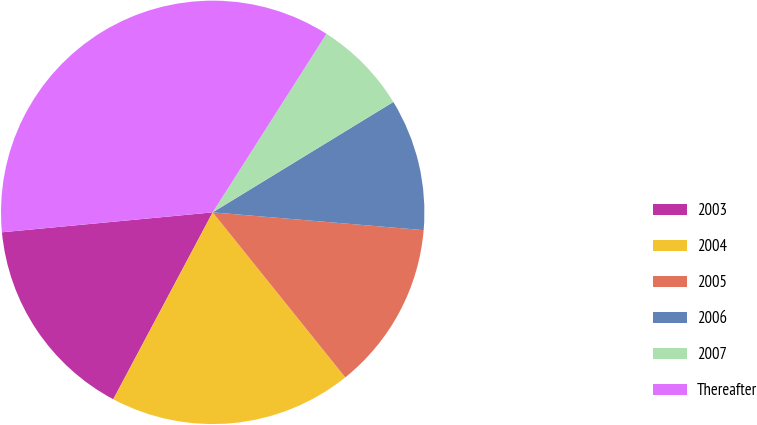Convert chart. <chart><loc_0><loc_0><loc_500><loc_500><pie_chart><fcel>2003<fcel>2004<fcel>2005<fcel>2006<fcel>2007<fcel>Thereafter<nl><fcel>15.72%<fcel>18.55%<fcel>12.89%<fcel>10.07%<fcel>7.24%<fcel>35.53%<nl></chart> 